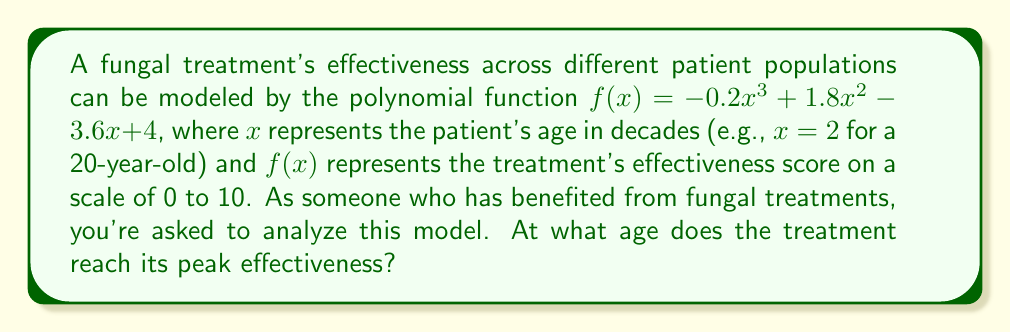Give your solution to this math problem. To find the age at which the treatment reaches peak effectiveness, we need to follow these steps:

1) The peak effectiveness occurs at the maximum point of the function. To find this, we need to determine where the derivative of the function equals zero.

2) Let's find the derivative of $f(x)$:
   $f'(x) = -0.6x^2 + 3.6x - 3.6$

3) Set the derivative equal to zero and solve for $x$:
   $-0.6x^2 + 3.6x - 3.6 = 0$

4) This is a quadratic equation. We can solve it using the quadratic formula:
   $x = \frac{-b \pm \sqrt{b^2 - 4ac}}{2a}$

   Where $a = -0.6$, $b = 3.6$, and $c = -3.6$

5) Plugging these values into the quadratic formula:
   $x = \frac{-3.6 \pm \sqrt{3.6^2 - 4(-0.6)(-3.6)}}{2(-0.6)}$

6) Simplifying:
   $x = \frac{-3.6 \pm \sqrt{12.96 - 8.64}}{-1.2} = \frac{-3.6 \pm \sqrt{4.32}}{-1.2} = \frac{-3.6 \pm 2.08}{-1.2}$

7) This gives us two solutions:
   $x_1 = \frac{-3.6 + 2.08}{-1.2} = 1.27$
   $x_2 = \frac{-3.6 - 2.08}{-1.2} = 4.73$

8) To determine which of these is the maximum (rather than the minimum), we can check the second derivative:
   $f''(x) = -1.2x + 3.6$
   
   At $x = 1.27$, $f''(1.27) = 2.076 > 0$, indicating this is a local minimum.
   At $x = 4.73$, $f''(4.73) = -2.076 < 0$, indicating this is a local maximum.

9) Therefore, the treatment reaches its peak effectiveness at $x = 4.73$ decades.

10) Converting back to years: $4.73 * 10 = 47.3$ years old.
Answer: 47.3 years old 